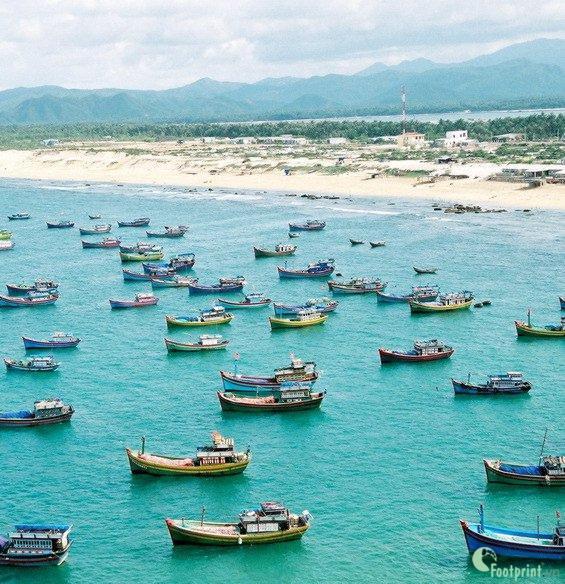What is the name of the boat pictured?
Concise answer only. Sailboat. Are the boats sinking?
Quick response, please. No. How many boats are on the blue water?
Keep it brief. 43. 